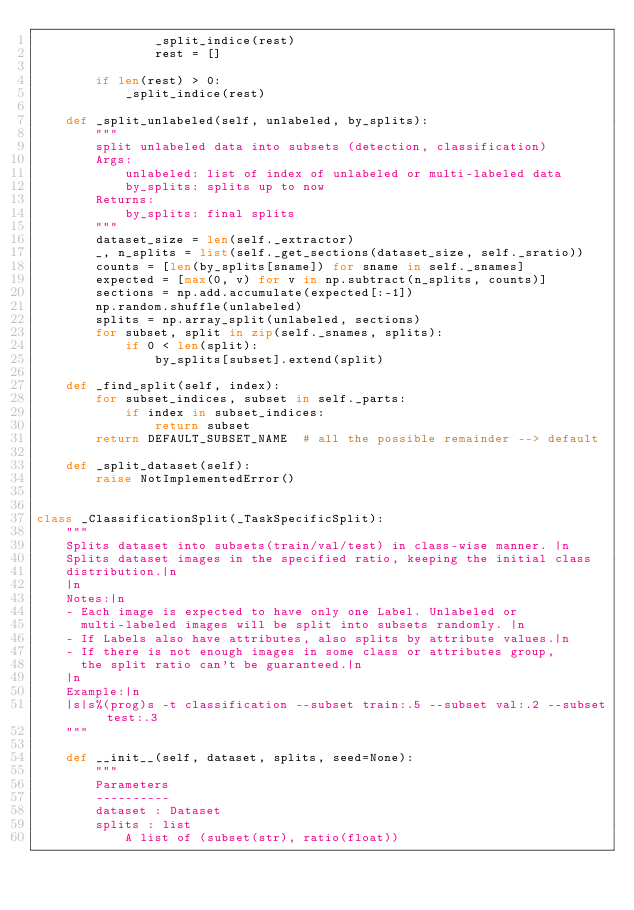Convert code to text. <code><loc_0><loc_0><loc_500><loc_500><_Python_>                _split_indice(rest)
                rest = []

        if len(rest) > 0:
            _split_indice(rest)

    def _split_unlabeled(self, unlabeled, by_splits):
        """
        split unlabeled data into subsets (detection, classification)
        Args:
            unlabeled: list of index of unlabeled or multi-labeled data
            by_splits: splits up to now
        Returns:
            by_splits: final splits
        """
        dataset_size = len(self._extractor)
        _, n_splits = list(self._get_sections(dataset_size, self._sratio))
        counts = [len(by_splits[sname]) for sname in self._snames]
        expected = [max(0, v) for v in np.subtract(n_splits, counts)]
        sections = np.add.accumulate(expected[:-1])
        np.random.shuffle(unlabeled)
        splits = np.array_split(unlabeled, sections)
        for subset, split in zip(self._snames, splits):
            if 0 < len(split):
                by_splits[subset].extend(split)

    def _find_split(self, index):
        for subset_indices, subset in self._parts:
            if index in subset_indices:
                return subset
        return DEFAULT_SUBSET_NAME  # all the possible remainder --> default

    def _split_dataset(self):
        raise NotImplementedError()


class _ClassificationSplit(_TaskSpecificSplit):
    """
    Splits dataset into subsets(train/val/test) in class-wise manner. |n
    Splits dataset images in the specified ratio, keeping the initial class
    distribution.|n
    |n
    Notes:|n
    - Each image is expected to have only one Label. Unlabeled or
      multi-labeled images will be split into subsets randomly. |n
    - If Labels also have attributes, also splits by attribute values.|n
    - If there is not enough images in some class or attributes group,
      the split ratio can't be guaranteed.|n
    |n
    Example:|n
    |s|s%(prog)s -t classification --subset train:.5 --subset val:.2 --subset test:.3
    """

    def __init__(self, dataset, splits, seed=None):
        """
        Parameters
        ----------
        dataset : Dataset
        splits : list
            A list of (subset(str), ratio(float))</code> 